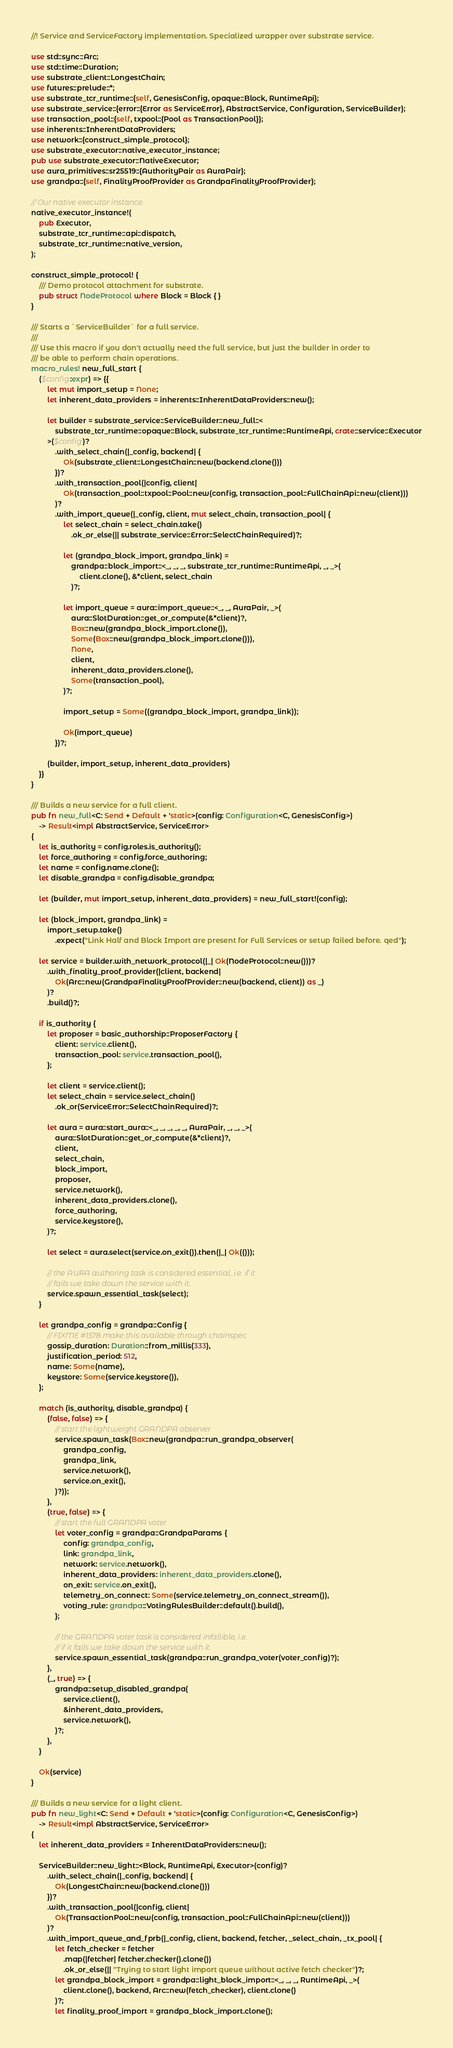Convert code to text. <code><loc_0><loc_0><loc_500><loc_500><_Rust_>//! Service and ServiceFactory implementation. Specialized wrapper over substrate service.

use std::sync::Arc;
use std::time::Duration;
use substrate_client::LongestChain;
use futures::prelude::*;
use substrate_tcr_runtime::{self, GenesisConfig, opaque::Block, RuntimeApi};
use substrate_service::{error::{Error as ServiceError}, AbstractService, Configuration, ServiceBuilder};
use transaction_pool::{self, txpool::{Pool as TransactionPool}};
use inherents::InherentDataProviders;
use network::{construct_simple_protocol};
use substrate_executor::native_executor_instance;
pub use substrate_executor::NativeExecutor;
use aura_primitives::sr25519::{AuthorityPair as AuraPair};
use grandpa::{self, FinalityProofProvider as GrandpaFinalityProofProvider};

// Our native executor instance.
native_executor_instance!(
	pub Executor,
	substrate_tcr_runtime::api::dispatch,
	substrate_tcr_runtime::native_version,
);

construct_simple_protocol! {
	/// Demo protocol attachment for substrate.
	pub struct NodeProtocol where Block = Block { }
}

/// Starts a `ServiceBuilder` for a full service.
///
/// Use this macro if you don't actually need the full service, but just the builder in order to
/// be able to perform chain operations.
macro_rules! new_full_start {
	($config:expr) => {{
		let mut import_setup = None;
		let inherent_data_providers = inherents::InherentDataProviders::new();

		let builder = substrate_service::ServiceBuilder::new_full::<
			substrate_tcr_runtime::opaque::Block, substrate_tcr_runtime::RuntimeApi, crate::service::Executor
		>($config)?
			.with_select_chain(|_config, backend| {
				Ok(substrate_client::LongestChain::new(backend.clone()))
			})?
			.with_transaction_pool(|config, client|
				Ok(transaction_pool::txpool::Pool::new(config, transaction_pool::FullChainApi::new(client)))
			)?
			.with_import_queue(|_config, client, mut select_chain, transaction_pool| {
				let select_chain = select_chain.take()
					.ok_or_else(|| substrate_service::Error::SelectChainRequired)?;

				let (grandpa_block_import, grandpa_link) =
					grandpa::block_import::<_, _, _, substrate_tcr_runtime::RuntimeApi, _, _>(
						client.clone(), &*client, select_chain
					)?;

				let import_queue = aura::import_queue::<_, _, AuraPair, _>(
					aura::SlotDuration::get_or_compute(&*client)?,
					Box::new(grandpa_block_import.clone()),
					Some(Box::new(grandpa_block_import.clone())),
					None,
					client,
					inherent_data_providers.clone(),
					Some(transaction_pool),
				)?;

				import_setup = Some((grandpa_block_import, grandpa_link));

				Ok(import_queue)
			})?;

		(builder, import_setup, inherent_data_providers)
	}}
}

/// Builds a new service for a full client.
pub fn new_full<C: Send + Default + 'static>(config: Configuration<C, GenesisConfig>)
	-> Result<impl AbstractService, ServiceError>
{
	let is_authority = config.roles.is_authority();
	let force_authoring = config.force_authoring;
	let name = config.name.clone();
	let disable_grandpa = config.disable_grandpa;

	let (builder, mut import_setup, inherent_data_providers) = new_full_start!(config);

	let (block_import, grandpa_link) =
		import_setup.take()
			.expect("Link Half and Block Import are present for Full Services or setup failed before. qed");

	let service = builder.with_network_protocol(|_| Ok(NodeProtocol::new()))?
		.with_finality_proof_provider(|client, backend|
			Ok(Arc::new(GrandpaFinalityProofProvider::new(backend, client)) as _)
		)?
		.build()?;

	if is_authority {
		let proposer = basic_authorship::ProposerFactory {
			client: service.client(),
			transaction_pool: service.transaction_pool(),
		};

		let client = service.client();
		let select_chain = service.select_chain()
			.ok_or(ServiceError::SelectChainRequired)?;

		let aura = aura::start_aura::<_, _, _, _, _, AuraPair, _, _, _>(
			aura::SlotDuration::get_or_compute(&*client)?,
			client,
			select_chain,
			block_import,
			proposer,
			service.network(),
			inherent_data_providers.clone(),
			force_authoring,
			service.keystore(),
		)?;

		let select = aura.select(service.on_exit()).then(|_| Ok(()));

		// the AURA authoring task is considered essential, i.e. if it
		// fails we take down the service with it.
		service.spawn_essential_task(select);
	}

	let grandpa_config = grandpa::Config {
		// FIXME #1578 make this available through chainspec
		gossip_duration: Duration::from_millis(333),
		justification_period: 512,
		name: Some(name),
		keystore: Some(service.keystore()),
	};

	match (is_authority, disable_grandpa) {
		(false, false) => {
			// start the lightweight GRANDPA observer
			service.spawn_task(Box::new(grandpa::run_grandpa_observer(
				grandpa_config,
				grandpa_link,
				service.network(),
				service.on_exit(),
			)?));
		},
		(true, false) => {
			// start the full GRANDPA voter
			let voter_config = grandpa::GrandpaParams {
				config: grandpa_config,
				link: grandpa_link,
				network: service.network(),
				inherent_data_providers: inherent_data_providers.clone(),
				on_exit: service.on_exit(),
				telemetry_on_connect: Some(service.telemetry_on_connect_stream()),
				voting_rule: grandpa::VotingRulesBuilder::default().build(),
			};

			// the GRANDPA voter task is considered infallible, i.e.
			// if it fails we take down the service with it.
			service.spawn_essential_task(grandpa::run_grandpa_voter(voter_config)?);
		},
		(_, true) => {
			grandpa::setup_disabled_grandpa(
				service.client(),
				&inherent_data_providers,
				service.network(),
			)?;
		},
	}

	Ok(service)
}

/// Builds a new service for a light client.
pub fn new_light<C: Send + Default + 'static>(config: Configuration<C, GenesisConfig>)
	-> Result<impl AbstractService, ServiceError>
{
	let inherent_data_providers = InherentDataProviders::new();

	ServiceBuilder::new_light::<Block, RuntimeApi, Executor>(config)?
		.with_select_chain(|_config, backend| {
			Ok(LongestChain::new(backend.clone()))
		})?
		.with_transaction_pool(|config, client|
			Ok(TransactionPool::new(config, transaction_pool::FullChainApi::new(client)))
		)?
		.with_import_queue_and_fprb(|_config, client, backend, fetcher, _select_chain, _tx_pool| {
			let fetch_checker = fetcher
				.map(|fetcher| fetcher.checker().clone())
				.ok_or_else(|| "Trying to start light import queue without active fetch checker")?;
			let grandpa_block_import = grandpa::light_block_import::<_, _, _, RuntimeApi, _>(
				client.clone(), backend, Arc::new(fetch_checker), client.clone()
			)?;
			let finality_proof_import = grandpa_block_import.clone();</code> 